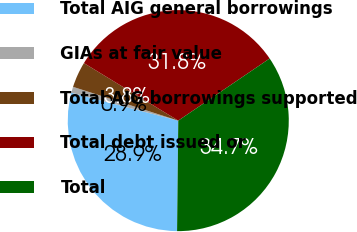Convert chart to OTSL. <chart><loc_0><loc_0><loc_500><loc_500><pie_chart><fcel>Total AIG general borrowings<fcel>GIAs at fair value<fcel>Total AIG borrowings supported<fcel>Total debt issued or<fcel>Total<nl><fcel>28.89%<fcel>0.88%<fcel>3.77%<fcel>31.78%<fcel>34.67%<nl></chart> 